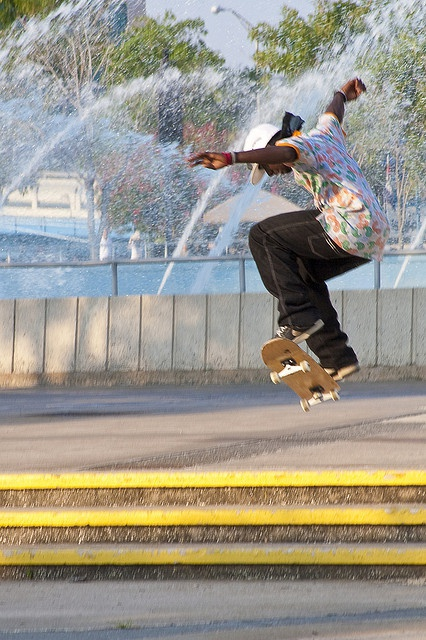Describe the objects in this image and their specific colors. I can see people in olive, black, darkgray, gray, and lightgray tones and skateboard in olive, gray, ivory, and tan tones in this image. 